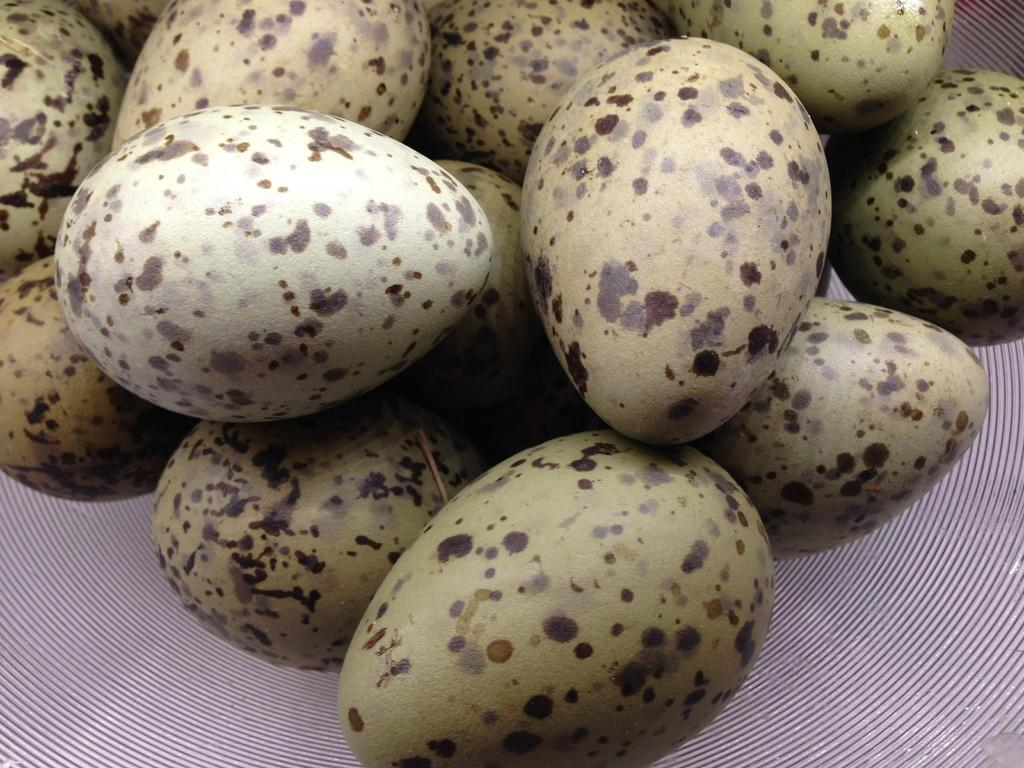What is present in the image? There are eggs in the image. Where are the eggs located? The eggs are on a surface. Can you describe the appearance of the eggs? The eggs have black color spots on them. How many snakes are slithering around the eggs in the image? There are no snakes present in the image; it only features eggs with black color spots. Who is the writer of the text on the eggs in the image? There is no text on the eggs in the image, so it cannot be determined who the writer might be. 